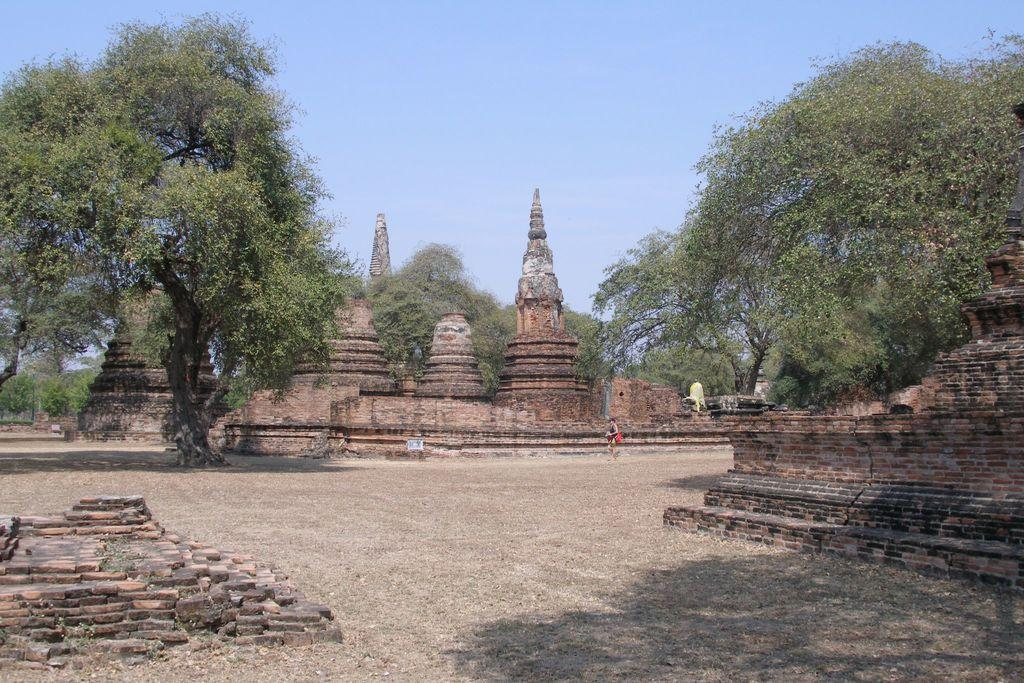What type of structures are located at the center of the image? There are brick structures at the center of the image. What type of vegetation is present in the image? There are trees in the image. What type of surface is visible in the image? There is grass on the surface in the image. What can be seen in the background of the image? The sky is visible in the background of the image. What type of pot is being used to hold the popcorn in the image? There is no popcorn or pot present in the image. How many fingers can be seen pointing at the trees in the image? There are no fingers visible in the image; it only shows brick structures, trees, grass, and the sky. 